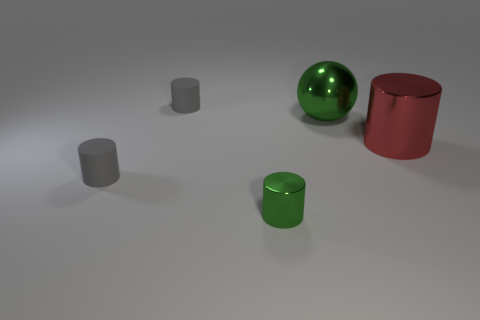Subtract all red metallic cylinders. How many cylinders are left? 3 Add 1 big metallic cylinders. How many objects exist? 6 Subtract all red cylinders. How many cylinders are left? 3 Subtract all green cubes. How many gray cylinders are left? 2 Subtract all cylinders. How many objects are left? 1 Subtract all brown balls. Subtract all cyan cylinders. How many balls are left? 1 Subtract all green metal cylinders. Subtract all metallic cylinders. How many objects are left? 2 Add 4 red metallic objects. How many red metallic objects are left? 5 Add 5 cylinders. How many cylinders exist? 9 Subtract 0 blue cylinders. How many objects are left? 5 